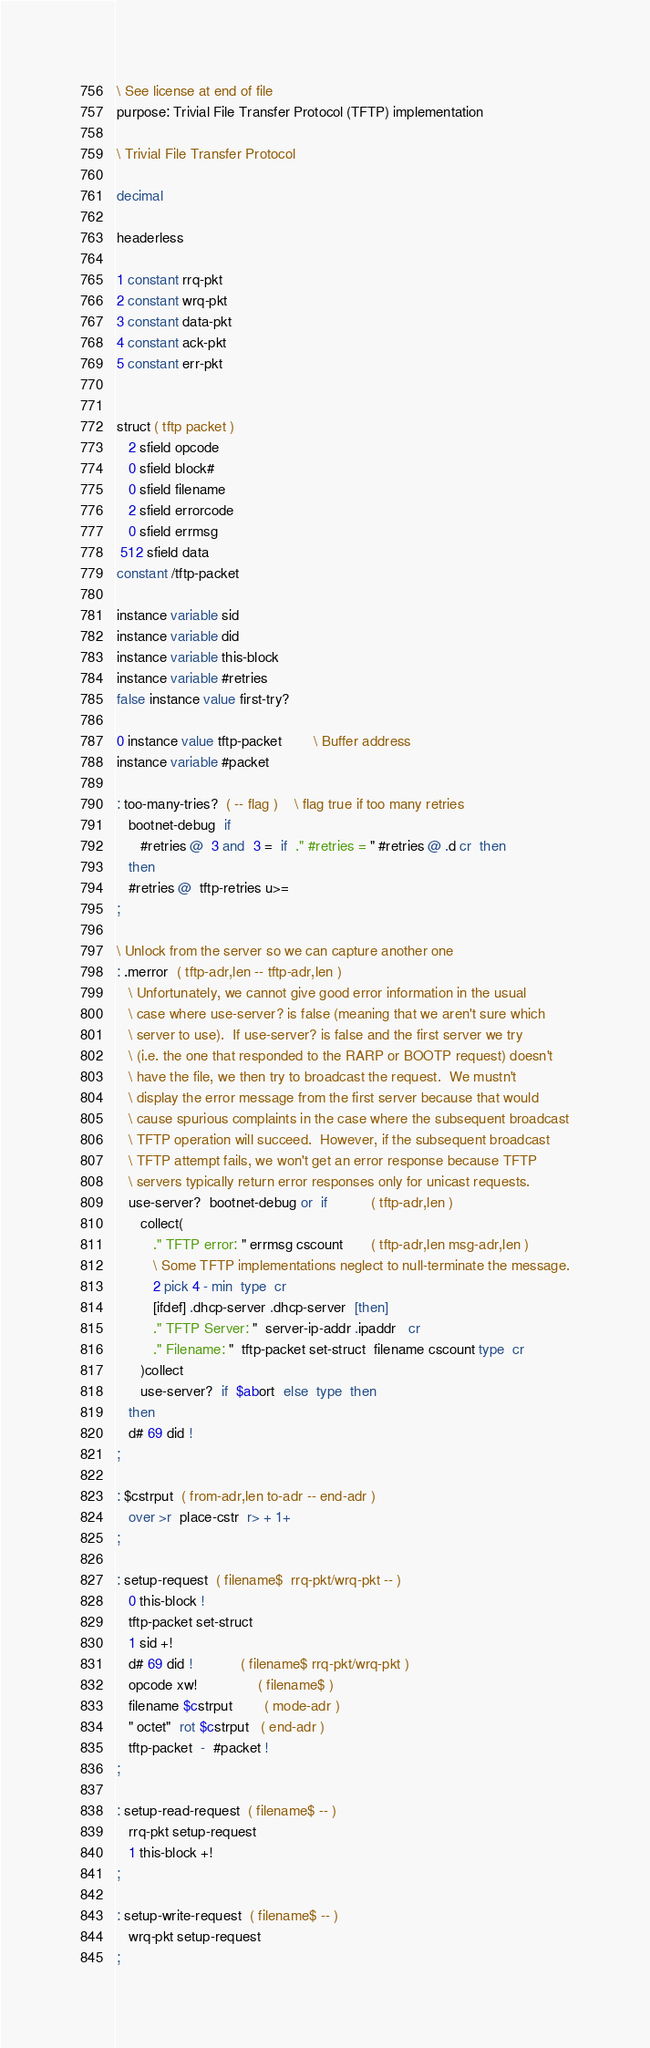Convert code to text. <code><loc_0><loc_0><loc_500><loc_500><_Forth_>\ See license at end of file
purpose: Trivial File Transfer Protocol (TFTP) implementation

\ Trivial File Transfer Protocol

decimal

headerless

1 constant rrq-pkt
2 constant wrq-pkt
3 constant data-pkt
4 constant ack-pkt
5 constant err-pkt


struct ( tftp packet )
   2 sfield opcode
   0 sfield block#
   0 sfield filename
   2 sfield errorcode
   0 sfield errmsg
 512 sfield data
constant /tftp-packet

instance variable sid
instance variable did
instance variable this-block
instance variable #retries
false instance value first-try?

0 instance value tftp-packet		\ Buffer address
instance variable #packet

: too-many-tries?  ( -- flag )	\ flag true if too many retries
   bootnet-debug  if
      #retries @  3 and  3 =  if  ." #retries = " #retries @ .d cr  then
   then
   #retries @  tftp-retries u>=
;

\ Unlock from the server so we can capture another one
: .merror  ( tftp-adr,len -- tftp-adr,len )
   \ Unfortunately, we cannot give good error information in the usual
   \ case where use-server? is false (meaning that we aren't sure which
   \ server to use).  If use-server? is false and the first server we try
   \ (i.e. the one that responded to the RARP or BOOTP request) doesn't
   \ have the file, we then try to broadcast the request.  We mustn't
   \ display the error message from the first server because that would
   \ cause spurious complaints in the case where the subsequent broadcast
   \ TFTP operation will succeed.  However, if the subsequent broadcast
   \ TFTP attempt fails, we won't get an error response because TFTP
   \ servers typically return error responses only for unicast requests.
   use-server?  bootnet-debug or  if           ( tftp-adr,len )
      collect(
         ." TFTP error: " errmsg cscount       ( tftp-adr,len msg-adr,len )
         \ Some TFTP implementations neglect to null-terminate the message.
         2 pick 4 - min  type  cr
         [ifdef] .dhcp-server .dhcp-server  [then]
         ." TFTP Server: "  server-ip-addr .ipaddr   cr
         ." Filename: "  tftp-packet set-struct  filename cscount type  cr
      )collect
      use-server?  if  $abort  else  type  then
   then
   d# 69 did !
;

: $cstrput  ( from-adr,len to-adr -- end-adr )
   over >r  place-cstr  r> + 1+
;

: setup-request  ( filename$  rrq-pkt/wrq-pkt -- )
   0 this-block !
   tftp-packet set-struct
   1 sid +!
   d# 69 did !		    ( filename$ rrq-pkt/wrq-pkt )
   opcode xw!               ( filename$ )
   filename $cstrput        ( mode-adr )
   " octet"  rot $cstrput   ( end-adr )
   tftp-packet  -  #packet !
;

: setup-read-request  ( filename$ -- )
   rrq-pkt setup-request
   1 this-block +!
;

: setup-write-request  ( filename$ -- )
   wrq-pkt setup-request
;
</code> 